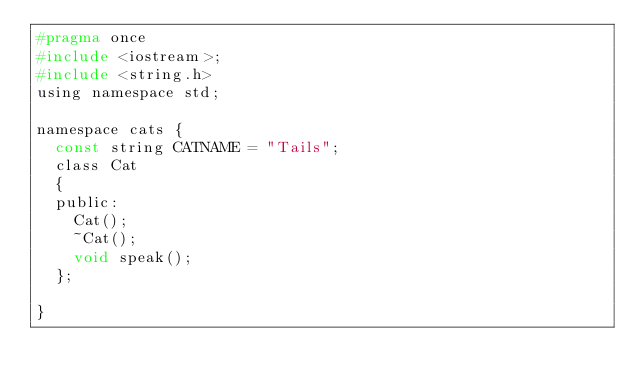<code> <loc_0><loc_0><loc_500><loc_500><_C_>#pragma once
#include <iostream>;
#include <string.h>
using namespace std;

namespace cats {
	const string CATNAME = "Tails";
	class Cat
	{
	public:
		Cat();
		~Cat();
		void speak();
	};

}
</code> 